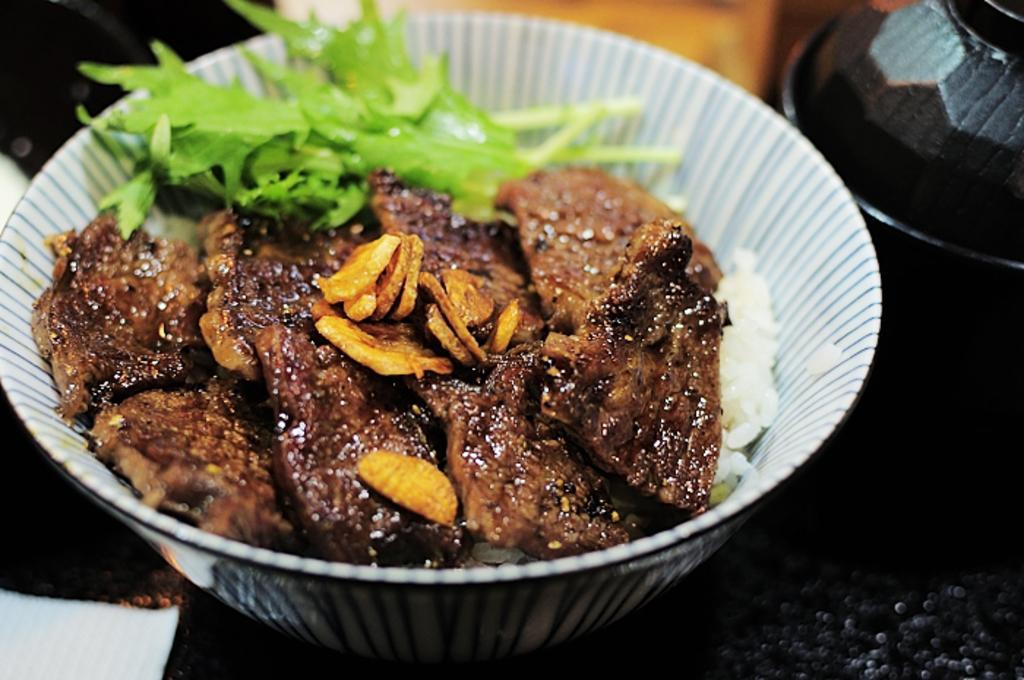In one or two sentences, can you explain what this image depicts? In this image there are food items in the bowl. Beside the bowl there is another bowl on the table. 